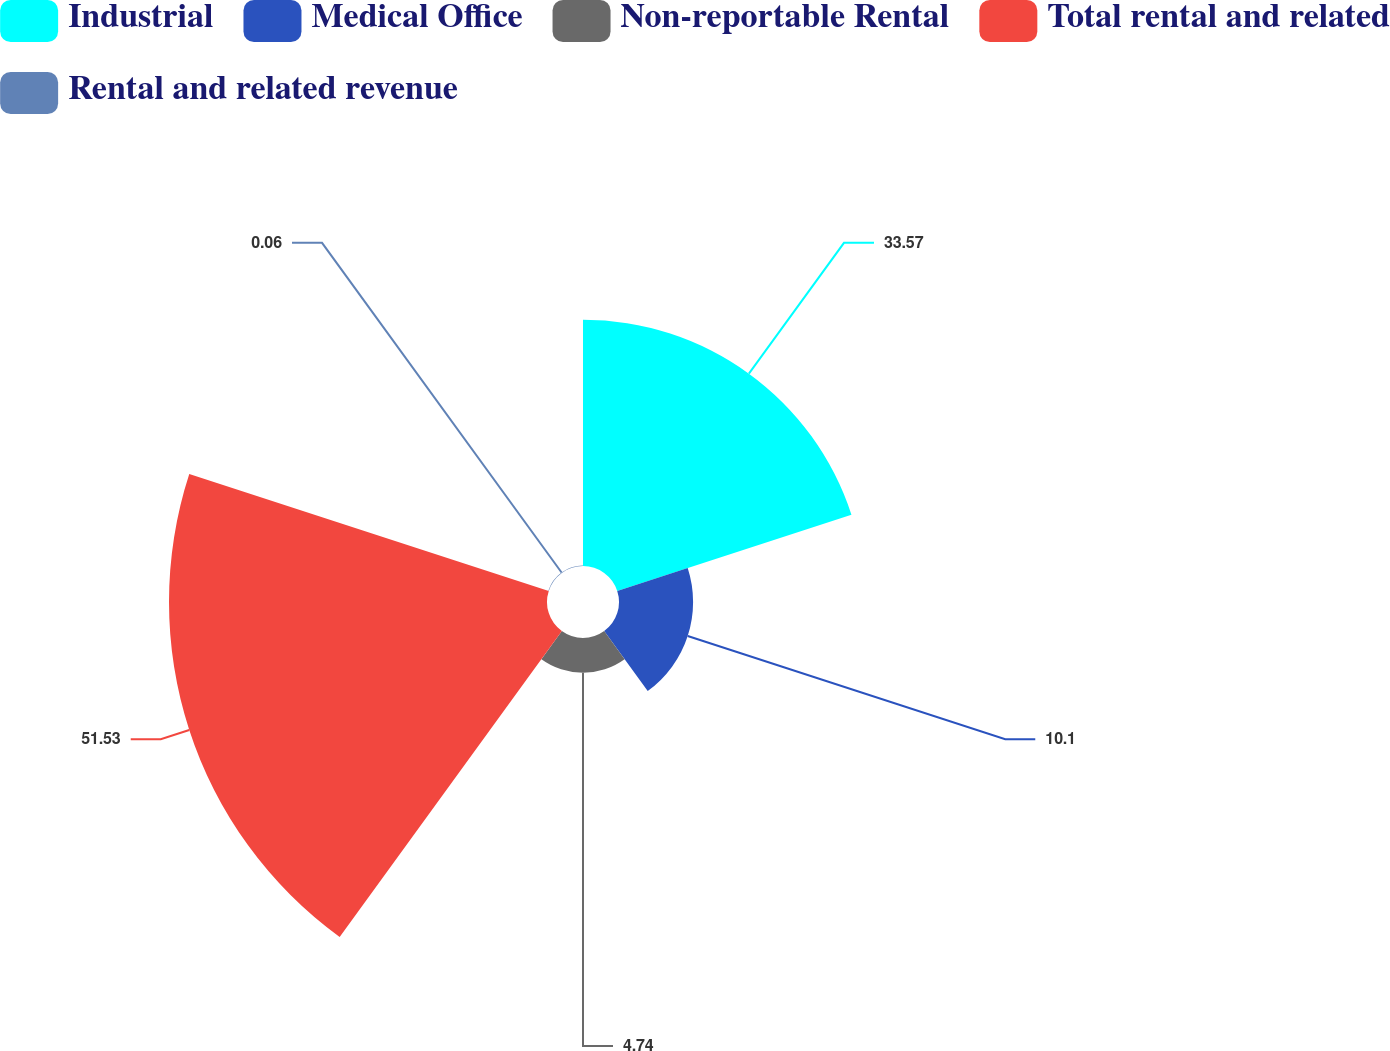Convert chart. <chart><loc_0><loc_0><loc_500><loc_500><pie_chart><fcel>Industrial<fcel>Medical Office<fcel>Non-reportable Rental<fcel>Total rental and related<fcel>Rental and related revenue<nl><fcel>33.57%<fcel>10.1%<fcel>4.74%<fcel>51.53%<fcel>0.06%<nl></chart> 